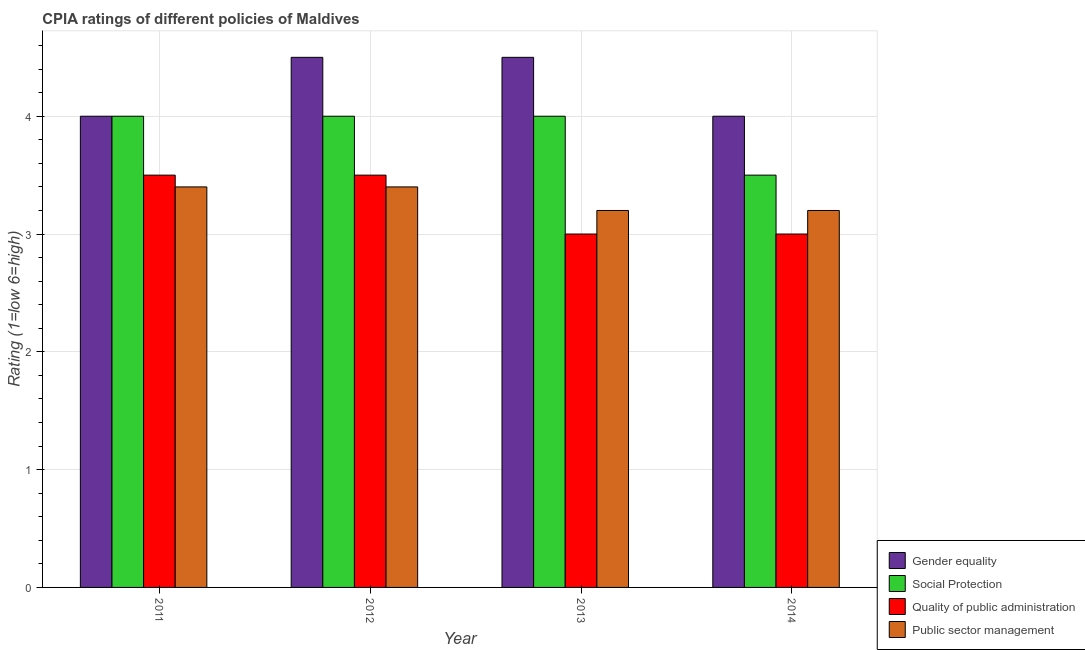How many different coloured bars are there?
Offer a terse response. 4. How many groups of bars are there?
Your response must be concise. 4. Are the number of bars on each tick of the X-axis equal?
Your response must be concise. Yes. What is the label of the 2nd group of bars from the left?
Ensure brevity in your answer.  2012. In how many cases, is the number of bars for a given year not equal to the number of legend labels?
Provide a succinct answer. 0. Across all years, what is the maximum cpia rating of public sector management?
Your response must be concise. 3.4. In which year was the cpia rating of public sector management maximum?
Keep it short and to the point. 2011. In which year was the cpia rating of quality of public administration minimum?
Provide a succinct answer. 2013. What is the average cpia rating of social protection per year?
Your response must be concise. 3.88. In how many years, is the cpia rating of gender equality greater than 1.6?
Your answer should be compact. 4. What is the ratio of the cpia rating of quality of public administration in 2011 to that in 2013?
Make the answer very short. 1.17. What is the difference between the highest and the lowest cpia rating of public sector management?
Give a very brief answer. 0.2. Is the sum of the cpia rating of social protection in 2012 and 2013 greater than the maximum cpia rating of gender equality across all years?
Make the answer very short. Yes. What does the 3rd bar from the left in 2014 represents?
Your answer should be very brief. Quality of public administration. What does the 4th bar from the right in 2013 represents?
Provide a short and direct response. Gender equality. How many bars are there?
Your answer should be very brief. 16. What is the difference between two consecutive major ticks on the Y-axis?
Offer a very short reply. 1. Are the values on the major ticks of Y-axis written in scientific E-notation?
Make the answer very short. No. Does the graph contain grids?
Ensure brevity in your answer.  Yes. Where does the legend appear in the graph?
Your response must be concise. Bottom right. What is the title of the graph?
Your answer should be compact. CPIA ratings of different policies of Maldives. What is the label or title of the X-axis?
Give a very brief answer. Year. What is the label or title of the Y-axis?
Offer a very short reply. Rating (1=low 6=high). What is the Rating (1=low 6=high) of Gender equality in 2011?
Provide a succinct answer. 4. What is the Rating (1=low 6=high) in Social Protection in 2011?
Make the answer very short. 4. What is the Rating (1=low 6=high) of Social Protection in 2012?
Your answer should be very brief. 4. What is the Rating (1=low 6=high) in Quality of public administration in 2012?
Offer a terse response. 3.5. What is the Rating (1=low 6=high) of Public sector management in 2013?
Your answer should be compact. 3.2. What is the Rating (1=low 6=high) in Quality of public administration in 2014?
Offer a very short reply. 3. What is the Rating (1=low 6=high) in Public sector management in 2014?
Give a very brief answer. 3.2. Across all years, what is the maximum Rating (1=low 6=high) of Gender equality?
Offer a very short reply. 4.5. Across all years, what is the maximum Rating (1=low 6=high) in Public sector management?
Your response must be concise. 3.4. What is the total Rating (1=low 6=high) in Social Protection in the graph?
Your answer should be very brief. 15.5. What is the total Rating (1=low 6=high) of Public sector management in the graph?
Keep it short and to the point. 13.2. What is the difference between the Rating (1=low 6=high) in Social Protection in 2011 and that in 2012?
Keep it short and to the point. 0. What is the difference between the Rating (1=low 6=high) of Quality of public administration in 2011 and that in 2012?
Your response must be concise. 0. What is the difference between the Rating (1=low 6=high) in Gender equality in 2011 and that in 2013?
Give a very brief answer. -0.5. What is the difference between the Rating (1=low 6=high) in Quality of public administration in 2011 and that in 2013?
Give a very brief answer. 0.5. What is the difference between the Rating (1=low 6=high) of Gender equality in 2011 and that in 2014?
Offer a very short reply. 0. What is the difference between the Rating (1=low 6=high) of Public sector management in 2011 and that in 2014?
Offer a terse response. 0.2. What is the difference between the Rating (1=low 6=high) in Social Protection in 2012 and that in 2013?
Ensure brevity in your answer.  0. What is the difference between the Rating (1=low 6=high) of Quality of public administration in 2012 and that in 2013?
Provide a succinct answer. 0.5. What is the difference between the Rating (1=low 6=high) in Public sector management in 2012 and that in 2013?
Your answer should be compact. 0.2. What is the difference between the Rating (1=low 6=high) of Social Protection in 2012 and that in 2014?
Keep it short and to the point. 0.5. What is the difference between the Rating (1=low 6=high) of Quality of public administration in 2012 and that in 2014?
Offer a terse response. 0.5. What is the difference between the Rating (1=low 6=high) of Quality of public administration in 2013 and that in 2014?
Your answer should be very brief. 0. What is the difference between the Rating (1=low 6=high) in Gender equality in 2011 and the Rating (1=low 6=high) in Social Protection in 2012?
Offer a very short reply. 0. What is the difference between the Rating (1=low 6=high) of Social Protection in 2011 and the Rating (1=low 6=high) of Quality of public administration in 2012?
Provide a short and direct response. 0.5. What is the difference between the Rating (1=low 6=high) in Gender equality in 2011 and the Rating (1=low 6=high) in Social Protection in 2013?
Your response must be concise. 0. What is the difference between the Rating (1=low 6=high) of Gender equality in 2011 and the Rating (1=low 6=high) of Quality of public administration in 2013?
Your answer should be compact. 1. What is the difference between the Rating (1=low 6=high) of Gender equality in 2011 and the Rating (1=low 6=high) of Public sector management in 2013?
Ensure brevity in your answer.  0.8. What is the difference between the Rating (1=low 6=high) in Social Protection in 2011 and the Rating (1=low 6=high) in Public sector management in 2013?
Provide a succinct answer. 0.8. What is the difference between the Rating (1=low 6=high) of Quality of public administration in 2011 and the Rating (1=low 6=high) of Public sector management in 2013?
Provide a short and direct response. 0.3. What is the difference between the Rating (1=low 6=high) in Gender equality in 2011 and the Rating (1=low 6=high) in Social Protection in 2014?
Your answer should be very brief. 0.5. What is the difference between the Rating (1=low 6=high) in Gender equality in 2011 and the Rating (1=low 6=high) in Public sector management in 2014?
Ensure brevity in your answer.  0.8. What is the difference between the Rating (1=low 6=high) in Quality of public administration in 2012 and the Rating (1=low 6=high) in Public sector management in 2013?
Make the answer very short. 0.3. What is the difference between the Rating (1=low 6=high) of Social Protection in 2012 and the Rating (1=low 6=high) of Public sector management in 2014?
Offer a very short reply. 0.8. What is the difference between the Rating (1=low 6=high) in Quality of public administration in 2012 and the Rating (1=low 6=high) in Public sector management in 2014?
Offer a very short reply. 0.3. What is the difference between the Rating (1=low 6=high) in Gender equality in 2013 and the Rating (1=low 6=high) in Quality of public administration in 2014?
Your response must be concise. 1.5. What is the difference between the Rating (1=low 6=high) in Social Protection in 2013 and the Rating (1=low 6=high) in Public sector management in 2014?
Your answer should be compact. 0.8. What is the average Rating (1=low 6=high) of Gender equality per year?
Give a very brief answer. 4.25. What is the average Rating (1=low 6=high) in Social Protection per year?
Your answer should be compact. 3.88. What is the average Rating (1=low 6=high) in Quality of public administration per year?
Provide a succinct answer. 3.25. In the year 2011, what is the difference between the Rating (1=low 6=high) of Gender equality and Rating (1=low 6=high) of Public sector management?
Ensure brevity in your answer.  0.6. In the year 2011, what is the difference between the Rating (1=low 6=high) of Social Protection and Rating (1=low 6=high) of Quality of public administration?
Provide a succinct answer. 0.5. In the year 2012, what is the difference between the Rating (1=low 6=high) of Gender equality and Rating (1=low 6=high) of Social Protection?
Keep it short and to the point. 0.5. In the year 2012, what is the difference between the Rating (1=low 6=high) of Gender equality and Rating (1=low 6=high) of Quality of public administration?
Give a very brief answer. 1. In the year 2012, what is the difference between the Rating (1=low 6=high) of Social Protection and Rating (1=low 6=high) of Quality of public administration?
Make the answer very short. 0.5. In the year 2012, what is the difference between the Rating (1=low 6=high) of Quality of public administration and Rating (1=low 6=high) of Public sector management?
Your response must be concise. 0.1. In the year 2013, what is the difference between the Rating (1=low 6=high) of Gender equality and Rating (1=low 6=high) of Social Protection?
Keep it short and to the point. 0.5. In the year 2013, what is the difference between the Rating (1=low 6=high) of Social Protection and Rating (1=low 6=high) of Quality of public administration?
Keep it short and to the point. 1. In the year 2013, what is the difference between the Rating (1=low 6=high) in Quality of public administration and Rating (1=low 6=high) in Public sector management?
Your answer should be very brief. -0.2. In the year 2014, what is the difference between the Rating (1=low 6=high) of Gender equality and Rating (1=low 6=high) of Social Protection?
Your answer should be very brief. 0.5. In the year 2014, what is the difference between the Rating (1=low 6=high) in Gender equality and Rating (1=low 6=high) in Public sector management?
Your answer should be compact. 0.8. What is the ratio of the Rating (1=low 6=high) of Gender equality in 2011 to that in 2012?
Your response must be concise. 0.89. What is the ratio of the Rating (1=low 6=high) of Social Protection in 2011 to that in 2012?
Offer a very short reply. 1. What is the ratio of the Rating (1=low 6=high) in Quality of public administration in 2011 to that in 2012?
Provide a succinct answer. 1. What is the ratio of the Rating (1=low 6=high) of Gender equality in 2011 to that in 2013?
Ensure brevity in your answer.  0.89. What is the ratio of the Rating (1=low 6=high) in Social Protection in 2011 to that in 2013?
Offer a very short reply. 1. What is the ratio of the Rating (1=low 6=high) in Quality of public administration in 2011 to that in 2013?
Provide a short and direct response. 1.17. What is the ratio of the Rating (1=low 6=high) in Social Protection in 2011 to that in 2014?
Your answer should be very brief. 1.14. What is the ratio of the Rating (1=low 6=high) of Gender equality in 2012 to that in 2013?
Ensure brevity in your answer.  1. What is the ratio of the Rating (1=low 6=high) of Social Protection in 2012 to that in 2013?
Your answer should be very brief. 1. What is the ratio of the Rating (1=low 6=high) of Public sector management in 2012 to that in 2013?
Offer a very short reply. 1.06. What is the ratio of the Rating (1=low 6=high) of Public sector management in 2012 to that in 2014?
Make the answer very short. 1.06. What is the ratio of the Rating (1=low 6=high) of Quality of public administration in 2013 to that in 2014?
Your answer should be very brief. 1. What is the difference between the highest and the second highest Rating (1=low 6=high) of Social Protection?
Your answer should be very brief. 0. What is the difference between the highest and the second highest Rating (1=low 6=high) of Public sector management?
Provide a short and direct response. 0. What is the difference between the highest and the lowest Rating (1=low 6=high) in Gender equality?
Offer a terse response. 0.5. 